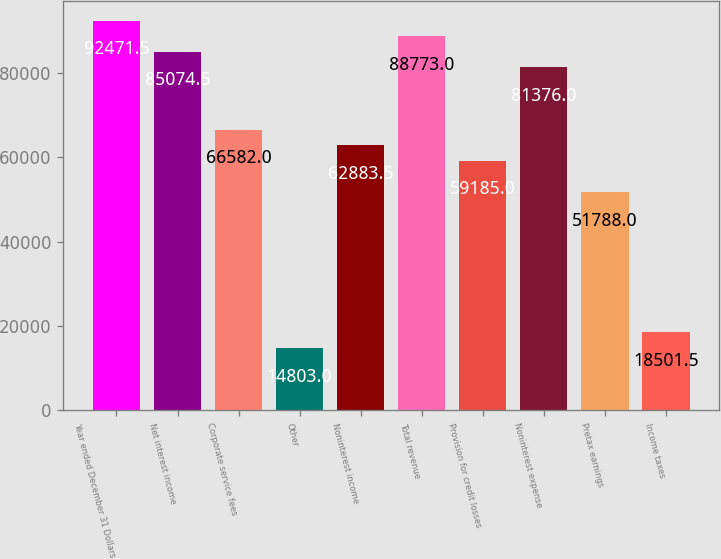Convert chart to OTSL. <chart><loc_0><loc_0><loc_500><loc_500><bar_chart><fcel>Year ended December 31 Dollars<fcel>Net interest income<fcel>Corporate service fees<fcel>Other<fcel>Noninterest income<fcel>Total revenue<fcel>Provision for credit losses<fcel>Noninterest expense<fcel>Pretax earnings<fcel>Income taxes<nl><fcel>92471.5<fcel>85074.5<fcel>66582<fcel>14803<fcel>62883.5<fcel>88773<fcel>59185<fcel>81376<fcel>51788<fcel>18501.5<nl></chart> 